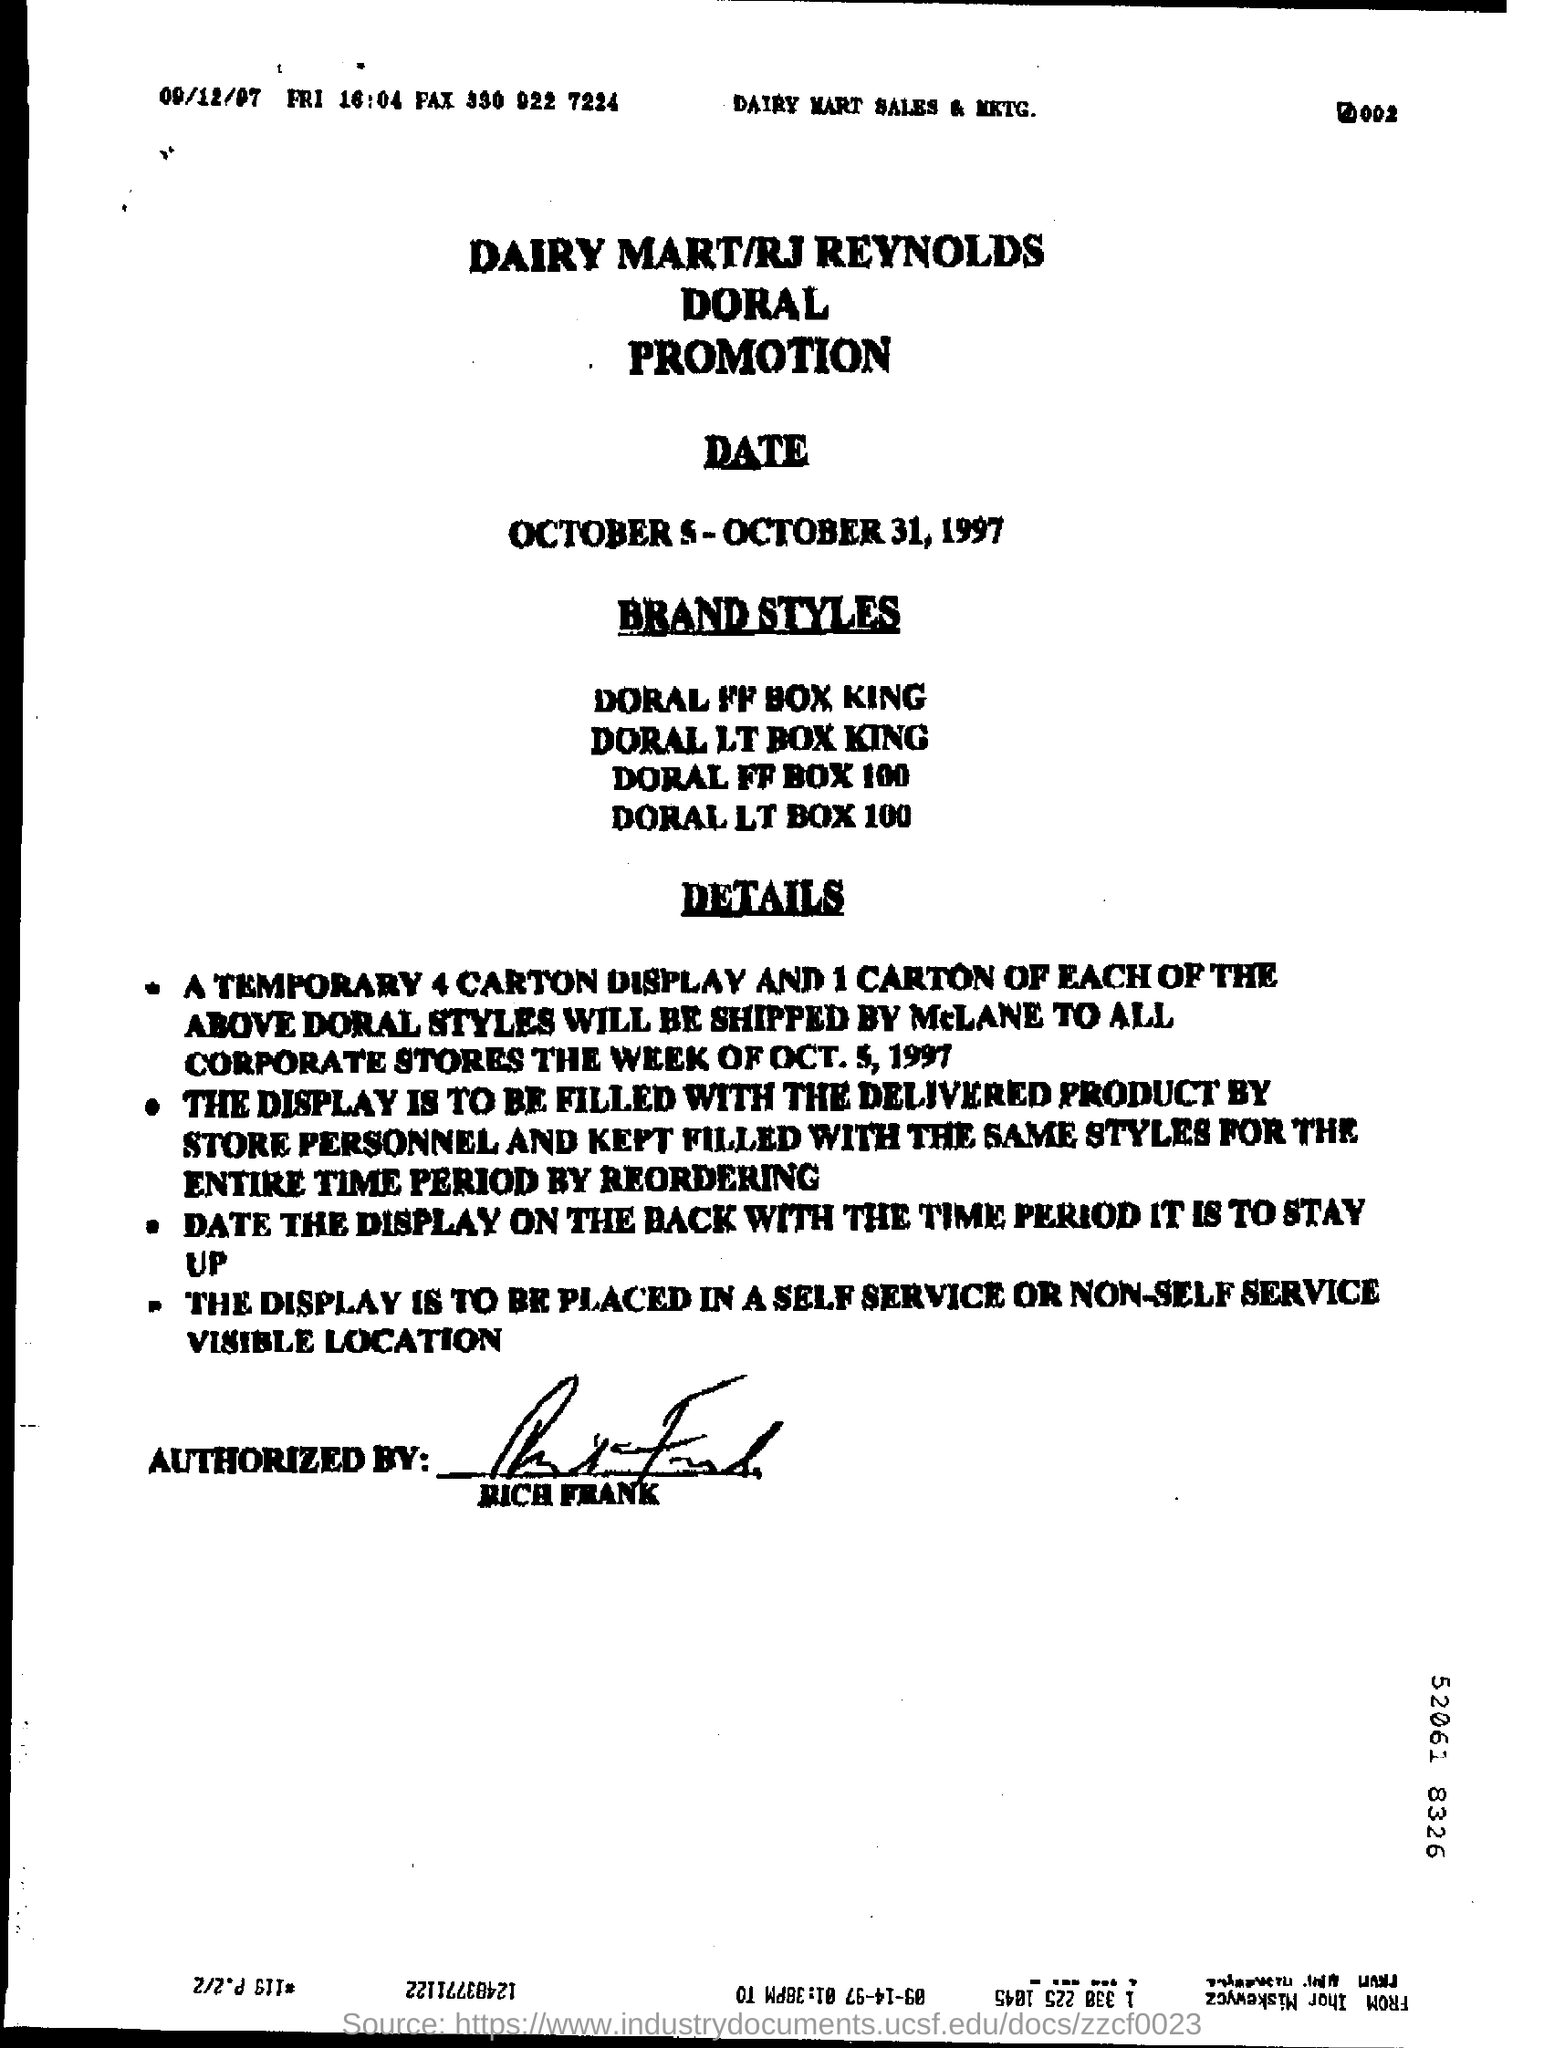Mention a couple of crucial points in this snapshot. The document has been signed by RICH FRANK. This promotion is offered by Dairy Mart, a brand affiliated with RJ Reynolds Doral, as part of their partnership. The promotion is scheduled to take place from October 5 to October 31, 1997. 